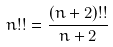Convert formula to latex. <formula><loc_0><loc_0><loc_500><loc_500>n ! ! = \frac { ( n + 2 ) ! ! } { n + 2 }</formula> 